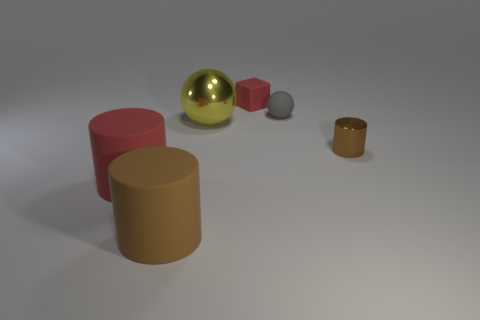What is the material of the object that is the same color as the block?
Keep it short and to the point. Rubber. There is a brown object that is left of the ball right of the metallic ball; what is its material?
Offer a very short reply. Rubber. There is a brown object that is the same size as the red rubber cylinder; what material is it?
Offer a terse response. Rubber. Does the matte cylinder that is on the right side of the red cylinder have the same size as the red rubber cube?
Give a very brief answer. No. There is a red thing that is behind the brown metal thing; is it the same shape as the big brown matte object?
Provide a short and direct response. No. What number of things are brown rubber cubes or things to the right of the yellow shiny sphere?
Your response must be concise. 3. Are there fewer tiny blue balls than yellow shiny objects?
Your answer should be compact. Yes. Are there more shiny balls than big matte objects?
Your answer should be very brief. No. How many other things are there of the same material as the small brown cylinder?
Give a very brief answer. 1. There is a red rubber object that is to the left of the red matte object behind the big metallic sphere; what number of big matte cylinders are in front of it?
Make the answer very short. 1. 